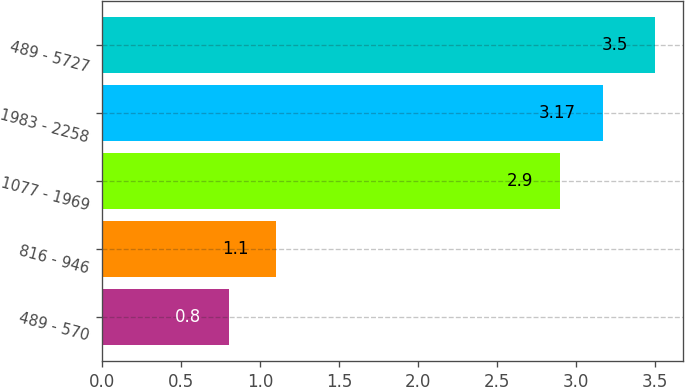Convert chart to OTSL. <chart><loc_0><loc_0><loc_500><loc_500><bar_chart><fcel>489 - 570<fcel>816 - 946<fcel>1077 - 1969<fcel>1983 - 2258<fcel>489 - 5727<nl><fcel>0.8<fcel>1.1<fcel>2.9<fcel>3.17<fcel>3.5<nl></chart> 